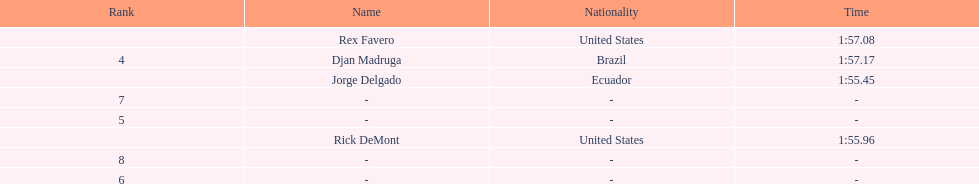What is the mean period? 1:56.42. 